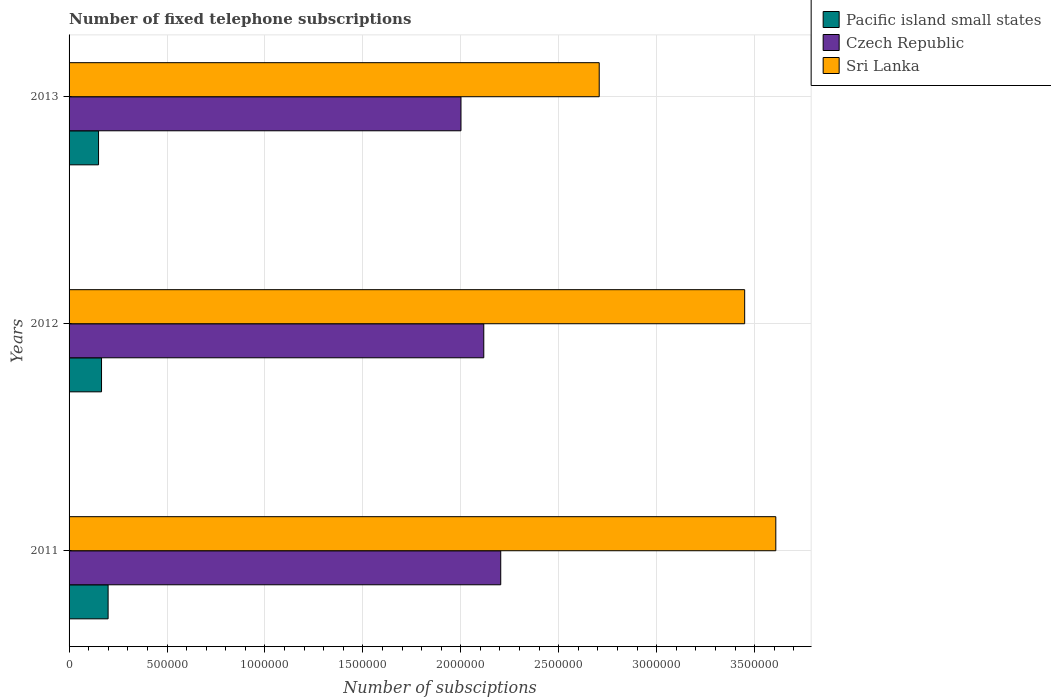How many bars are there on the 1st tick from the top?
Keep it short and to the point. 3. How many bars are there on the 2nd tick from the bottom?
Offer a very short reply. 3. What is the number of fixed telephone subscriptions in Pacific island small states in 2011?
Your answer should be compact. 1.99e+05. Across all years, what is the maximum number of fixed telephone subscriptions in Czech Republic?
Keep it short and to the point. 2.20e+06. Across all years, what is the minimum number of fixed telephone subscriptions in Czech Republic?
Offer a terse response. 2.00e+06. What is the total number of fixed telephone subscriptions in Czech Republic in the graph?
Provide a succinct answer. 6.32e+06. What is the difference between the number of fixed telephone subscriptions in Pacific island small states in 2011 and that in 2012?
Your answer should be compact. 3.36e+04. What is the difference between the number of fixed telephone subscriptions in Sri Lanka in 2013 and the number of fixed telephone subscriptions in Czech Republic in 2012?
Provide a succinct answer. 5.89e+05. What is the average number of fixed telephone subscriptions in Pacific island small states per year?
Ensure brevity in your answer.  1.72e+05. In the year 2012, what is the difference between the number of fixed telephone subscriptions in Pacific island small states and number of fixed telephone subscriptions in Czech Republic?
Give a very brief answer. -1.95e+06. What is the ratio of the number of fixed telephone subscriptions in Sri Lanka in 2011 to that in 2012?
Make the answer very short. 1.05. What is the difference between the highest and the second highest number of fixed telephone subscriptions in Pacific island small states?
Provide a short and direct response. 3.36e+04. What is the difference between the highest and the lowest number of fixed telephone subscriptions in Pacific island small states?
Your response must be concise. 4.89e+04. In how many years, is the number of fixed telephone subscriptions in Sri Lanka greater than the average number of fixed telephone subscriptions in Sri Lanka taken over all years?
Offer a very short reply. 2. Is the sum of the number of fixed telephone subscriptions in Czech Republic in 2012 and 2013 greater than the maximum number of fixed telephone subscriptions in Pacific island small states across all years?
Give a very brief answer. Yes. What does the 2nd bar from the top in 2011 represents?
Provide a short and direct response. Czech Republic. What does the 2nd bar from the bottom in 2011 represents?
Your answer should be compact. Czech Republic. How many bars are there?
Your answer should be very brief. 9. What is the difference between two consecutive major ticks on the X-axis?
Your answer should be compact. 5.00e+05. Are the values on the major ticks of X-axis written in scientific E-notation?
Your answer should be compact. No. How many legend labels are there?
Your answer should be compact. 3. How are the legend labels stacked?
Your answer should be compact. Vertical. What is the title of the graph?
Ensure brevity in your answer.  Number of fixed telephone subscriptions. Does "Central African Republic" appear as one of the legend labels in the graph?
Make the answer very short. No. What is the label or title of the X-axis?
Your response must be concise. Number of subsciptions. What is the Number of subsciptions in Pacific island small states in 2011?
Keep it short and to the point. 1.99e+05. What is the Number of subsciptions in Czech Republic in 2011?
Make the answer very short. 2.20e+06. What is the Number of subsciptions in Sri Lanka in 2011?
Your response must be concise. 3.61e+06. What is the Number of subsciptions in Pacific island small states in 2012?
Keep it short and to the point. 1.66e+05. What is the Number of subsciptions of Czech Republic in 2012?
Your answer should be very brief. 2.12e+06. What is the Number of subsciptions in Sri Lanka in 2012?
Your response must be concise. 3.45e+06. What is the Number of subsciptions in Pacific island small states in 2013?
Provide a short and direct response. 1.50e+05. What is the Number of subsciptions of Czech Republic in 2013?
Keep it short and to the point. 2.00e+06. What is the Number of subsciptions in Sri Lanka in 2013?
Provide a succinct answer. 2.71e+06. Across all years, what is the maximum Number of subsciptions of Pacific island small states?
Ensure brevity in your answer.  1.99e+05. Across all years, what is the maximum Number of subsciptions of Czech Republic?
Offer a terse response. 2.20e+06. Across all years, what is the maximum Number of subsciptions in Sri Lanka?
Ensure brevity in your answer.  3.61e+06. Across all years, what is the minimum Number of subsciptions in Pacific island small states?
Ensure brevity in your answer.  1.50e+05. Across all years, what is the minimum Number of subsciptions in Czech Republic?
Make the answer very short. 2.00e+06. Across all years, what is the minimum Number of subsciptions in Sri Lanka?
Give a very brief answer. 2.71e+06. What is the total Number of subsciptions in Pacific island small states in the graph?
Provide a succinct answer. 5.16e+05. What is the total Number of subsciptions in Czech Republic in the graph?
Offer a very short reply. 6.32e+06. What is the total Number of subsciptions in Sri Lanka in the graph?
Your response must be concise. 9.76e+06. What is the difference between the Number of subsciptions of Pacific island small states in 2011 and that in 2012?
Make the answer very short. 3.36e+04. What is the difference between the Number of subsciptions in Czech Republic in 2011 and that in 2012?
Offer a very short reply. 8.65e+04. What is the difference between the Number of subsciptions of Sri Lanka in 2011 and that in 2012?
Your response must be concise. 1.59e+05. What is the difference between the Number of subsciptions in Pacific island small states in 2011 and that in 2013?
Your answer should be very brief. 4.89e+04. What is the difference between the Number of subsciptions in Czech Republic in 2011 and that in 2013?
Your response must be concise. 2.03e+05. What is the difference between the Number of subsciptions of Sri Lanka in 2011 and that in 2013?
Your answer should be very brief. 9.02e+05. What is the difference between the Number of subsciptions of Pacific island small states in 2012 and that in 2013?
Keep it short and to the point. 1.53e+04. What is the difference between the Number of subsciptions of Czech Republic in 2012 and that in 2013?
Make the answer very short. 1.16e+05. What is the difference between the Number of subsciptions of Sri Lanka in 2012 and that in 2013?
Offer a terse response. 7.43e+05. What is the difference between the Number of subsciptions in Pacific island small states in 2011 and the Number of subsciptions in Czech Republic in 2012?
Provide a short and direct response. -1.92e+06. What is the difference between the Number of subsciptions of Pacific island small states in 2011 and the Number of subsciptions of Sri Lanka in 2012?
Keep it short and to the point. -3.25e+06. What is the difference between the Number of subsciptions in Czech Republic in 2011 and the Number of subsciptions in Sri Lanka in 2012?
Make the answer very short. -1.25e+06. What is the difference between the Number of subsciptions of Pacific island small states in 2011 and the Number of subsciptions of Czech Republic in 2013?
Provide a succinct answer. -1.80e+06. What is the difference between the Number of subsciptions in Pacific island small states in 2011 and the Number of subsciptions in Sri Lanka in 2013?
Offer a very short reply. -2.51e+06. What is the difference between the Number of subsciptions in Czech Republic in 2011 and the Number of subsciptions in Sri Lanka in 2013?
Your response must be concise. -5.03e+05. What is the difference between the Number of subsciptions of Pacific island small states in 2012 and the Number of subsciptions of Czech Republic in 2013?
Give a very brief answer. -1.84e+06. What is the difference between the Number of subsciptions in Pacific island small states in 2012 and the Number of subsciptions in Sri Lanka in 2013?
Give a very brief answer. -2.54e+06. What is the difference between the Number of subsciptions in Czech Republic in 2012 and the Number of subsciptions in Sri Lanka in 2013?
Keep it short and to the point. -5.89e+05. What is the average Number of subsciptions in Pacific island small states per year?
Your response must be concise. 1.72e+05. What is the average Number of subsciptions in Czech Republic per year?
Offer a terse response. 2.11e+06. What is the average Number of subsciptions in Sri Lanka per year?
Make the answer very short. 3.25e+06. In the year 2011, what is the difference between the Number of subsciptions of Pacific island small states and Number of subsciptions of Czech Republic?
Your response must be concise. -2.00e+06. In the year 2011, what is the difference between the Number of subsciptions in Pacific island small states and Number of subsciptions in Sri Lanka?
Offer a very short reply. -3.41e+06. In the year 2011, what is the difference between the Number of subsciptions of Czech Republic and Number of subsciptions of Sri Lanka?
Give a very brief answer. -1.40e+06. In the year 2012, what is the difference between the Number of subsciptions in Pacific island small states and Number of subsciptions in Czech Republic?
Provide a short and direct response. -1.95e+06. In the year 2012, what is the difference between the Number of subsciptions of Pacific island small states and Number of subsciptions of Sri Lanka?
Keep it short and to the point. -3.28e+06. In the year 2012, what is the difference between the Number of subsciptions of Czech Republic and Number of subsciptions of Sri Lanka?
Ensure brevity in your answer.  -1.33e+06. In the year 2013, what is the difference between the Number of subsciptions in Pacific island small states and Number of subsciptions in Czech Republic?
Make the answer very short. -1.85e+06. In the year 2013, what is the difference between the Number of subsciptions of Pacific island small states and Number of subsciptions of Sri Lanka?
Make the answer very short. -2.56e+06. In the year 2013, what is the difference between the Number of subsciptions of Czech Republic and Number of subsciptions of Sri Lanka?
Your response must be concise. -7.06e+05. What is the ratio of the Number of subsciptions of Pacific island small states in 2011 to that in 2012?
Offer a very short reply. 1.2. What is the ratio of the Number of subsciptions of Czech Republic in 2011 to that in 2012?
Offer a very short reply. 1.04. What is the ratio of the Number of subsciptions of Sri Lanka in 2011 to that in 2012?
Provide a short and direct response. 1.05. What is the ratio of the Number of subsciptions in Pacific island small states in 2011 to that in 2013?
Provide a succinct answer. 1.32. What is the ratio of the Number of subsciptions of Czech Republic in 2011 to that in 2013?
Make the answer very short. 1.1. What is the ratio of the Number of subsciptions of Sri Lanka in 2011 to that in 2013?
Ensure brevity in your answer.  1.33. What is the ratio of the Number of subsciptions in Pacific island small states in 2012 to that in 2013?
Your answer should be very brief. 1.1. What is the ratio of the Number of subsciptions of Czech Republic in 2012 to that in 2013?
Give a very brief answer. 1.06. What is the ratio of the Number of subsciptions in Sri Lanka in 2012 to that in 2013?
Ensure brevity in your answer.  1.27. What is the difference between the highest and the second highest Number of subsciptions of Pacific island small states?
Your response must be concise. 3.36e+04. What is the difference between the highest and the second highest Number of subsciptions of Czech Republic?
Give a very brief answer. 8.65e+04. What is the difference between the highest and the second highest Number of subsciptions in Sri Lanka?
Provide a succinct answer. 1.59e+05. What is the difference between the highest and the lowest Number of subsciptions in Pacific island small states?
Offer a very short reply. 4.89e+04. What is the difference between the highest and the lowest Number of subsciptions of Czech Republic?
Ensure brevity in your answer.  2.03e+05. What is the difference between the highest and the lowest Number of subsciptions of Sri Lanka?
Provide a short and direct response. 9.02e+05. 